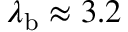Convert formula to latex. <formula><loc_0><loc_0><loc_500><loc_500>\lambda _ { b } \approx 3 . 2</formula> 